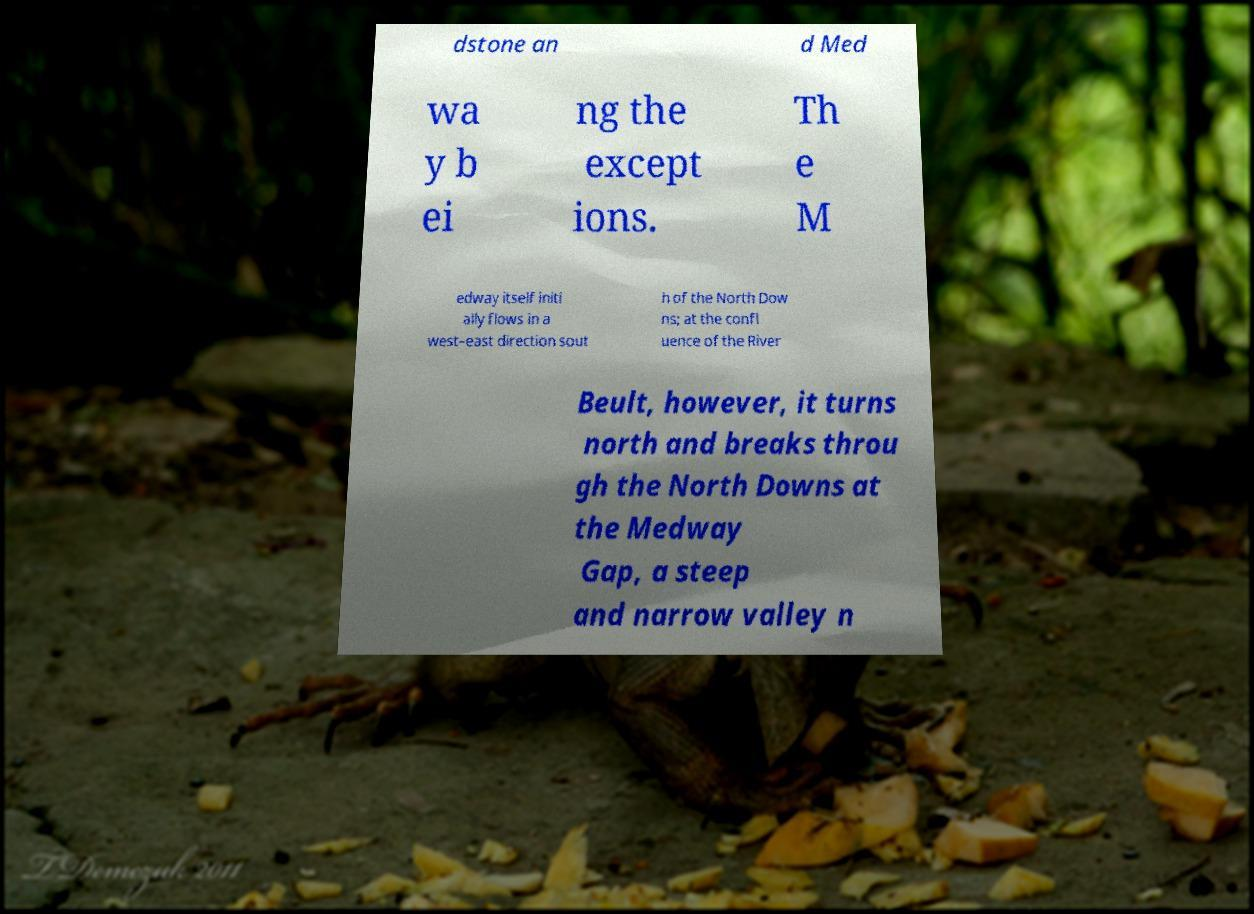There's text embedded in this image that I need extracted. Can you transcribe it verbatim? dstone an d Med wa y b ei ng the except ions. Th e M edway itself initi ally flows in a west–east direction sout h of the North Dow ns; at the confl uence of the River Beult, however, it turns north and breaks throu gh the North Downs at the Medway Gap, a steep and narrow valley n 